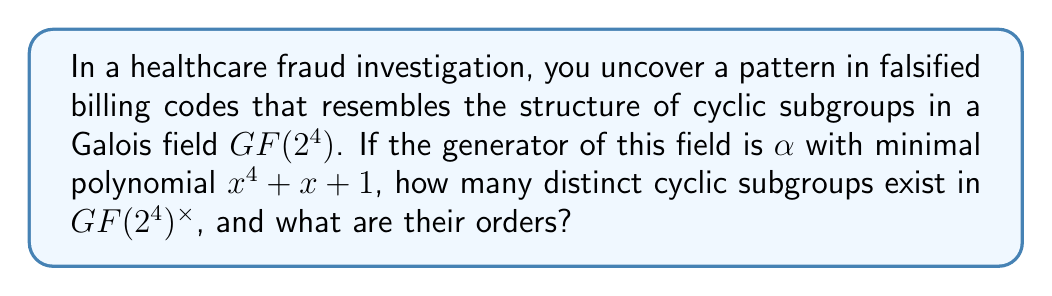What is the answer to this math problem? Let's approach this step-by-step:

1) First, recall that $GF(2^4)$ has $2^4 = 16$ elements, and $GF(2^4)^\times$ (the multiplicative group) has $15$ non-zero elements.

2) The order of $GF(2^4)^\times$ is 15, so by Lagrange's theorem, the possible orders of subgroups are the divisors of 15: 1, 3, 5, and 15.

3) To find the number of subgroups of each order:

   a) Order 1: Always only the identity element {1}. Count: 1
   
   b) Order 15: The entire group $GF(2^4)^\times$. Count: 1
   
   c) Order 3: Elements satisfying $x^3 = 1$ in $GF(2^4)^\times$. There are two such elements (plus the identity). Count: 1
   
   d) Order 5: Elements satisfying $x^5 = 1$ in $GF(2^4)^\times$. There are four such elements (plus the identity). Count: 1

4) Therefore, there are 4 distinct cyclic subgroups in total.

5) Their orders are 1, 3, 5, and 15.

This structure in the Galois field could be used to model the complexity and interrelations in the fraudulent billing codes, potentially revealing patterns or hierarchies in the fraudulent activity.
Answer: 4 cyclic subgroups with orders 1, 3, 5, and 15 